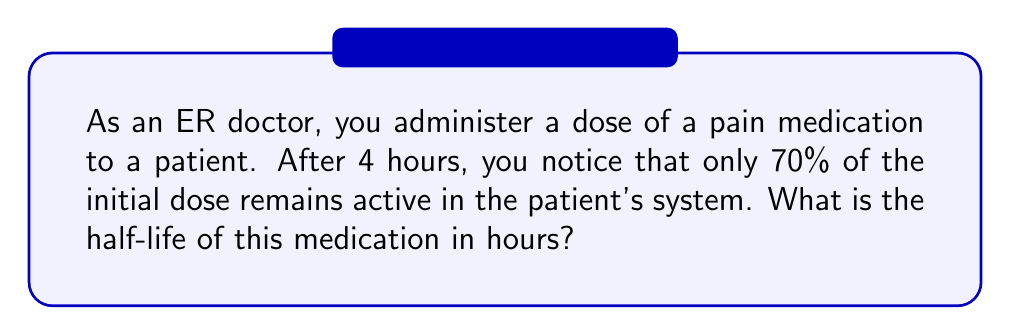Provide a solution to this math problem. Let's approach this step-by-step using the exponential decay formula:

1) The general form of exponential decay is:

   $$A(t) = A_0 \cdot e^{-kt}$$

   Where $A(t)$ is the amount at time $t$, $A_0$ is the initial amount, $k$ is the decay constant, and $t$ is time.

2) We know that after 4 hours, 70% of the initial dose remains. So:

   $$0.7 = e^{-4k}$$

3) Taking the natural log of both sides:

   $$\ln(0.7) = -4k$$

4) Solve for $k$:

   $$k = -\frac{\ln(0.7)}{4} \approx 0.0888$$

5) Now, we need to find the half-life. Half-life is the time it takes for half of the substance to decay. In the exponential decay formula, this is when $A(t) = 0.5A_0$:

   $$0.5 = e^{-k \cdot t_{1/2}}$$

6) Taking the natural log of both sides:

   $$\ln(0.5) = -k \cdot t_{1/2}$$

7) Solve for $t_{1/2}$:

   $$t_{1/2} = -\frac{\ln(0.5)}{k} = \frac{\ln(2)}{k}$$

8) Substitute the value of $k$ we found earlier:

   $$t_{1/2} = \frac{\ln(2)}{0.0888} \approx 7.81 \text{ hours}$$
Answer: 7.81 hours 